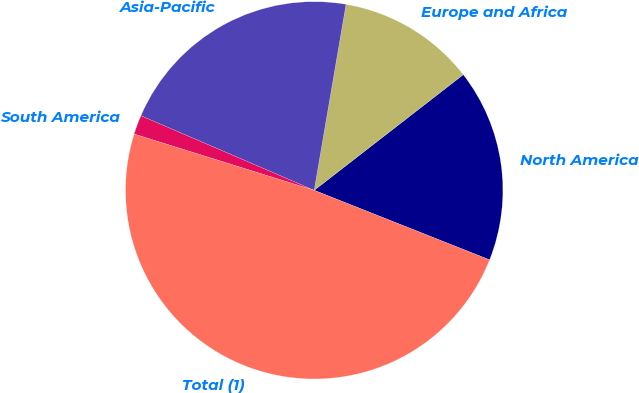Convert chart to OTSL. <chart><loc_0><loc_0><loc_500><loc_500><pie_chart><fcel>North America<fcel>Europe and Africa<fcel>Asia-Pacific<fcel>South America<fcel>Total (1)<nl><fcel>16.51%<fcel>11.8%<fcel>21.23%<fcel>1.65%<fcel>48.81%<nl></chart> 